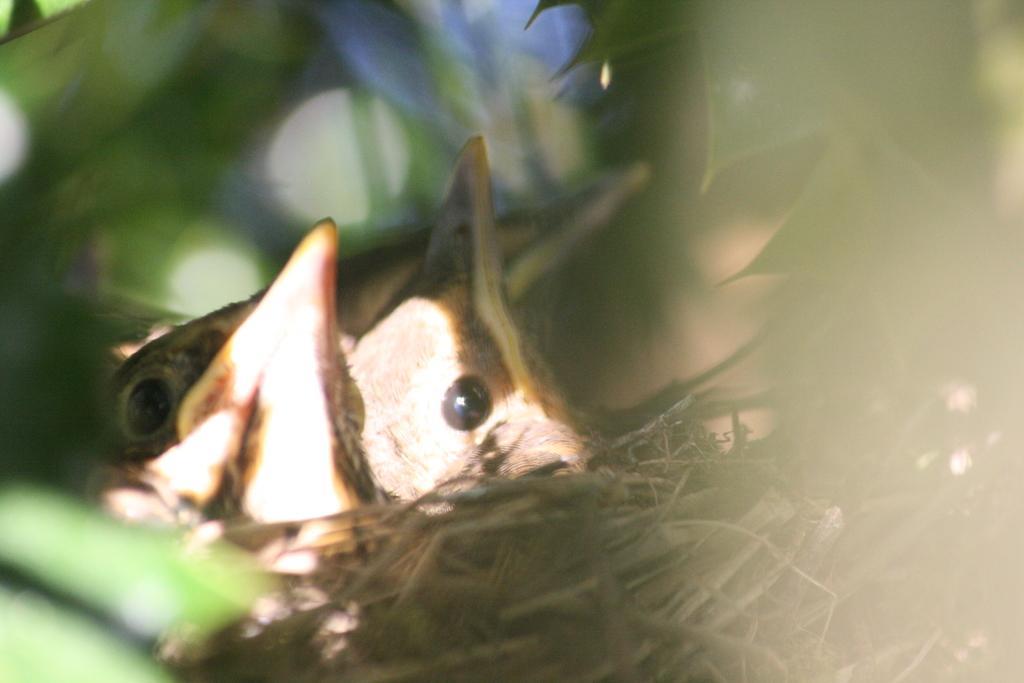Could you give a brief overview of what you see in this image? In this image I can see a nest and on it I can see three birds. I can also see number of leaves around the nest and I can see this image is little bit blurry. 